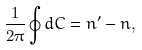Convert formula to latex. <formula><loc_0><loc_0><loc_500><loc_500>\frac { 1 } { 2 \pi } \oint d C = n ^ { \prime } - n ,</formula> 